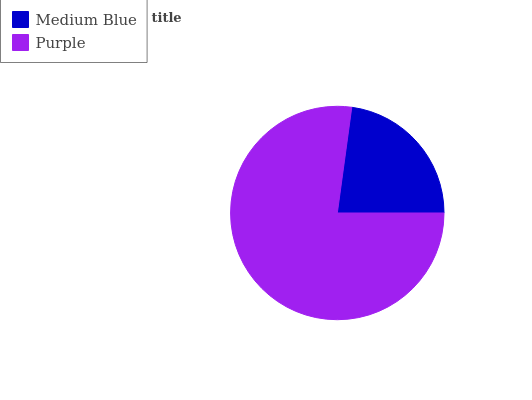Is Medium Blue the minimum?
Answer yes or no. Yes. Is Purple the maximum?
Answer yes or no. Yes. Is Purple the minimum?
Answer yes or no. No. Is Purple greater than Medium Blue?
Answer yes or no. Yes. Is Medium Blue less than Purple?
Answer yes or no. Yes. Is Medium Blue greater than Purple?
Answer yes or no. No. Is Purple less than Medium Blue?
Answer yes or no. No. Is Purple the high median?
Answer yes or no. Yes. Is Medium Blue the low median?
Answer yes or no. Yes. Is Medium Blue the high median?
Answer yes or no. No. Is Purple the low median?
Answer yes or no. No. 